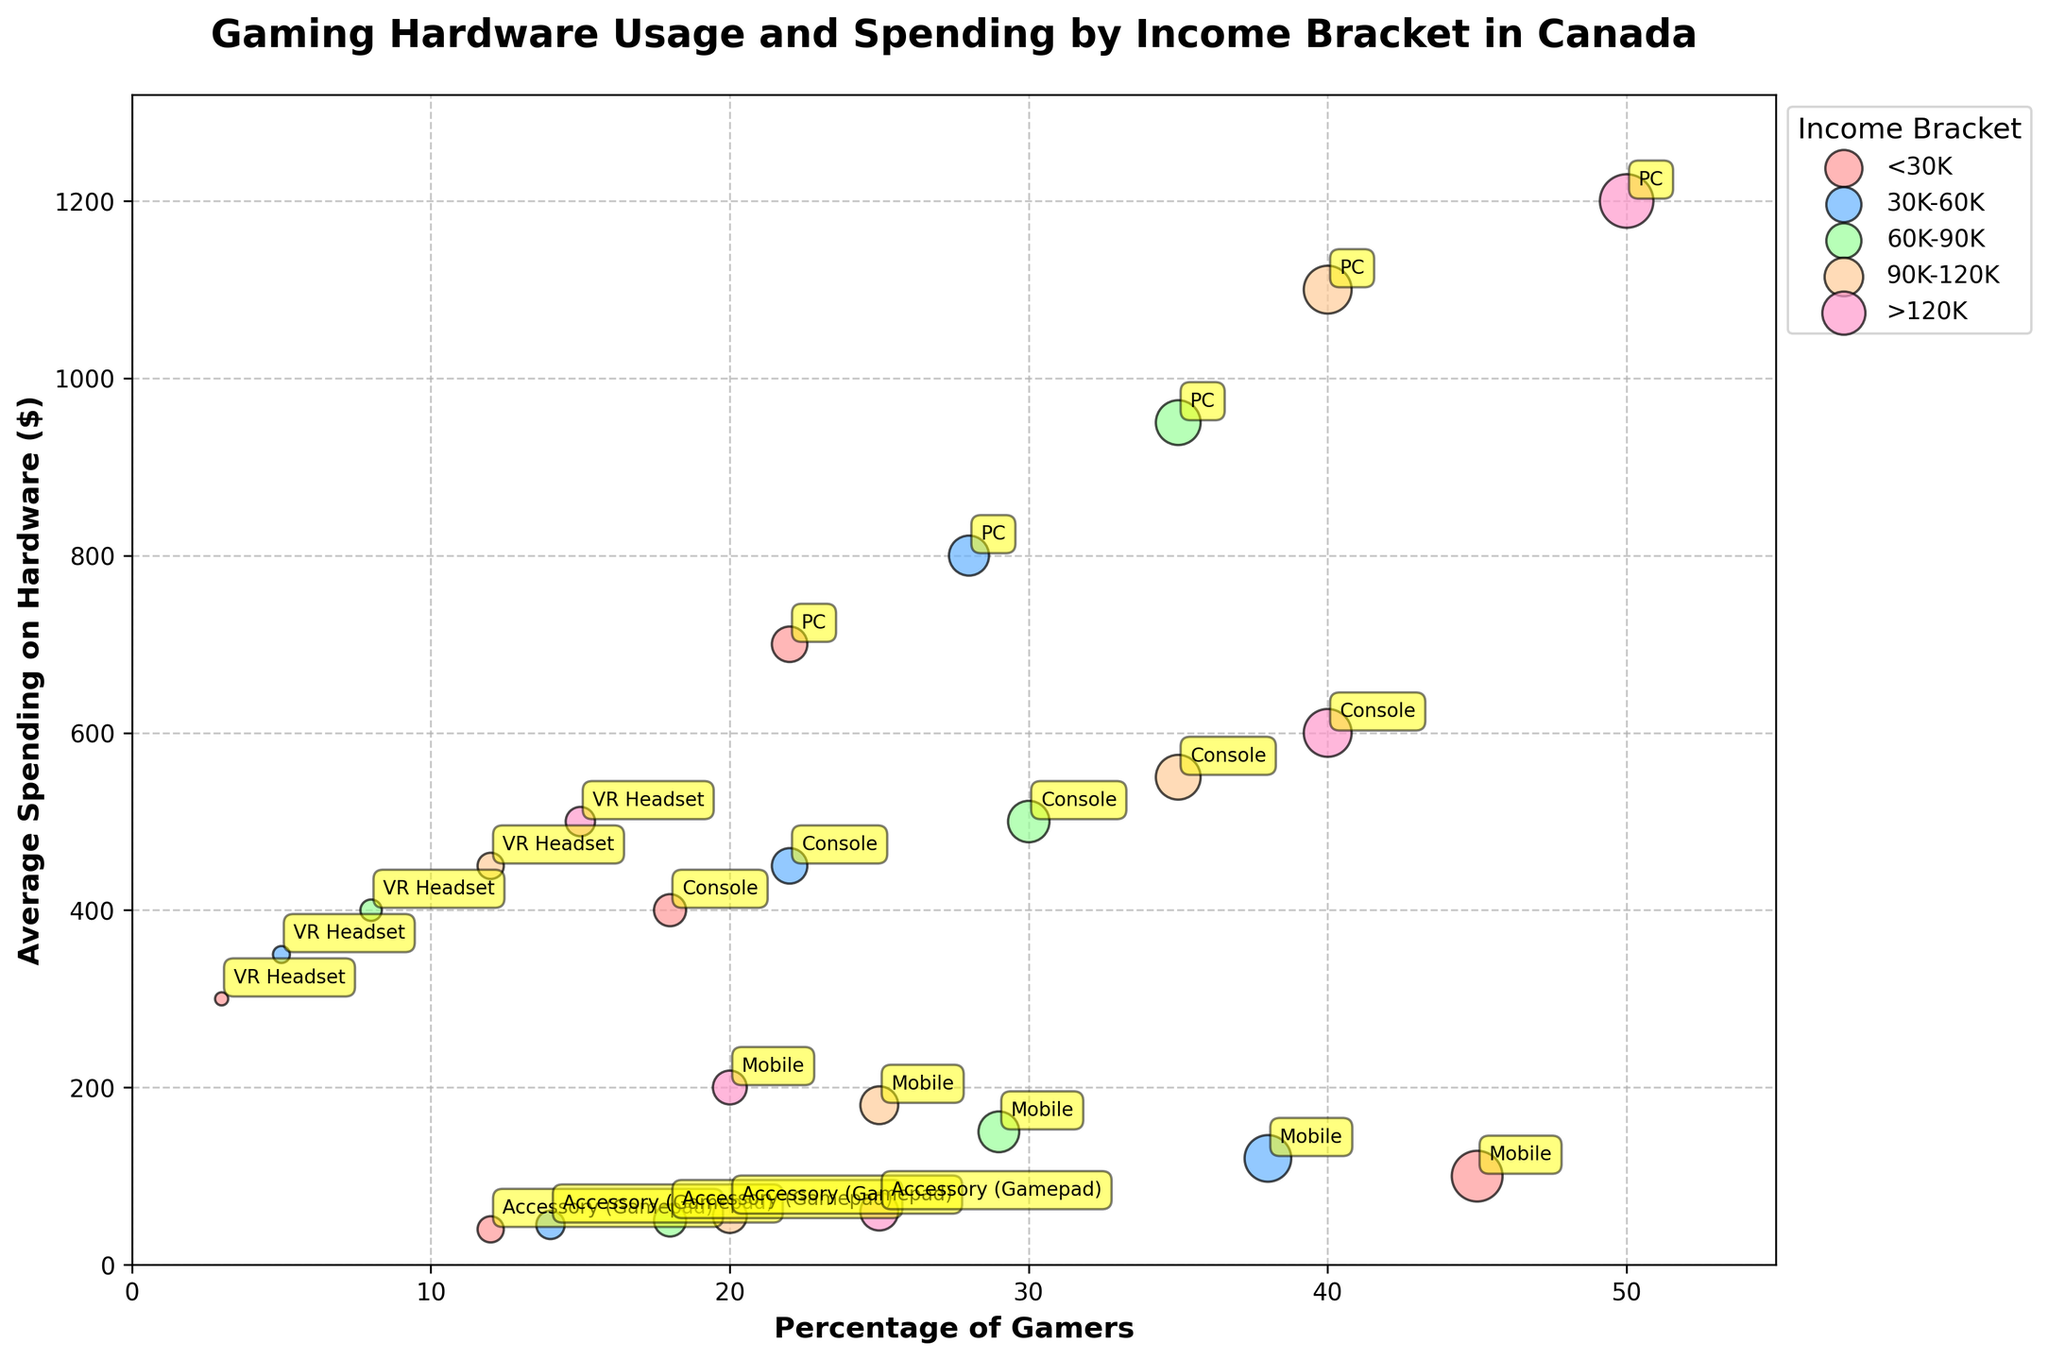What is the title of the figure? The title is usually placed above the figure. It provides a summary of what the figure is about.
Answer: Gaming Hardware Usage and Spending by Income Bracket in Canada Which income bracket has the highest percentage of gamers using VR headsets? Look at the bubble on the x-axis representing "Percentage of Gamers" for the VR Headset and find the one that has the highest value.
Answer: >120K What is the color of the bubbles representing the income bracket of 60K-90K? Identifying the colors used for different income brackets can be done by inspecting the legend.
Answer: #99FF99 (light green) What is the average spending on consoles for the income bracket 90K-120K? Locate the bubble for consoles within the 90K-120K income bracket and read the corresponding y-axis value.
Answer: 550 Which hardware type has the smallest bubble for the income bracket >120K? Smaller bubbles represent lower percentages. Find the bubble with the smallest size within the specified income bracket.
Answer: Mobile How does the average spending on hardware for PCs compare between the income brackets 60K-90K and 90K-120K? Locate the bubbles for PCs in both income brackets and compare their positions on the y-axis.
Answer: Higher in 90K-120K What is the income bracket with the lowest percentage of gamers using mobile devices? Identify the smallest x-axis value for mobile device bubbles.
Answer: >120K Which income bracket shows the highest average spending on any hardware type? Look for the highest y-axis value across all bubbles.
Answer: >120K (PC) Does the percentage of gamers using accessories (Gamepad) increase or decrease with higher income brackets? Compare x-axis values for accessories across the income brackets to determine the trend.
Answer: Increases What trend can you observe in the percentage of console users as income increases? Analyze the positions of the console bubbles across different income brackets on the x-axis to determine the trend.
Answer: Increases 